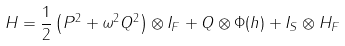<formula> <loc_0><loc_0><loc_500><loc_500>H = \frac { 1 } { 2 } \left ( P ^ { 2 } + \omega ^ { 2 } Q ^ { 2 } \right ) \otimes I _ { F } + Q \otimes \Phi ( h ) + I _ { S } \otimes H _ { F }</formula> 